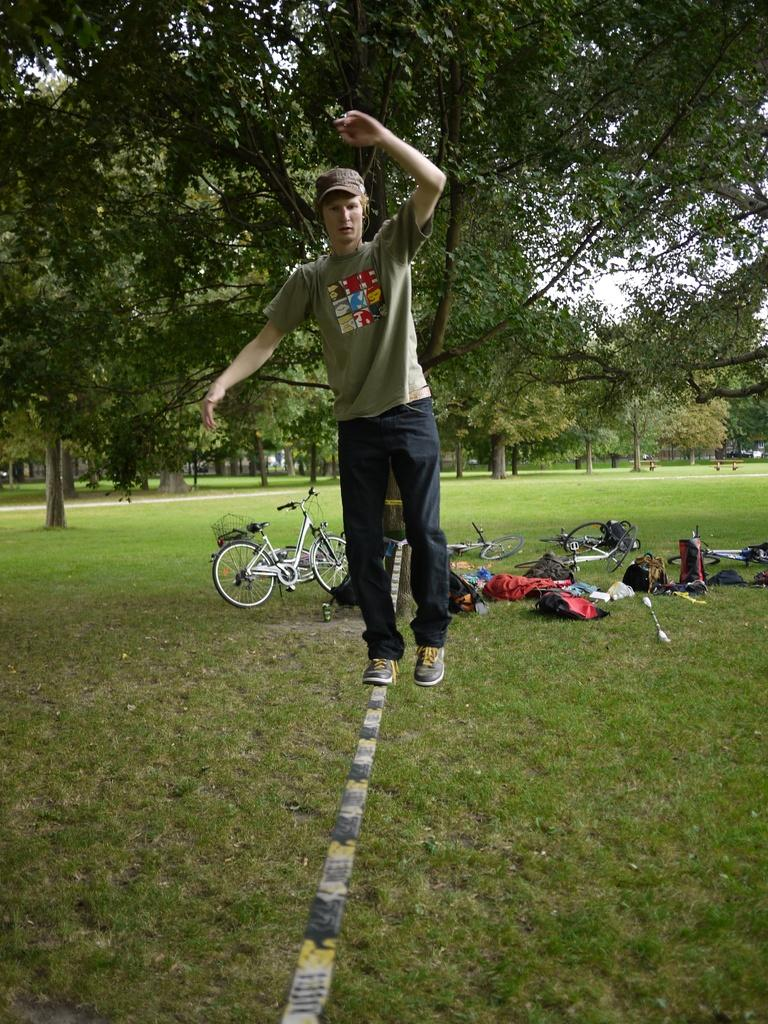What is the man in the image doing? The man is walking on a rope in the image. What can be seen in the background of the image? Trees, bicycles, and bags are visible in the background of the image. What type of terrain is at the bottom of the image? Grass is present at the bottom of the image. How many boats are visible in the image? There are no boats present in the image. What type of hose is being used by the man walking on the rope? There is no hose visible in the image; the man is simply walking on a rope. 